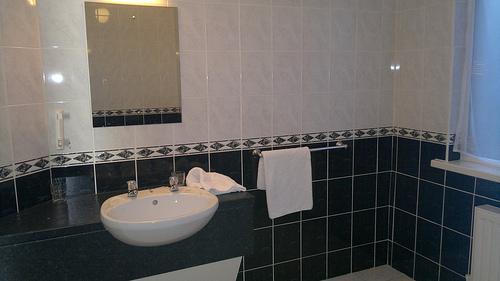How many towels?
Give a very brief answer. 2. How many of the towels are hung up?
Give a very brief answer. 1. 